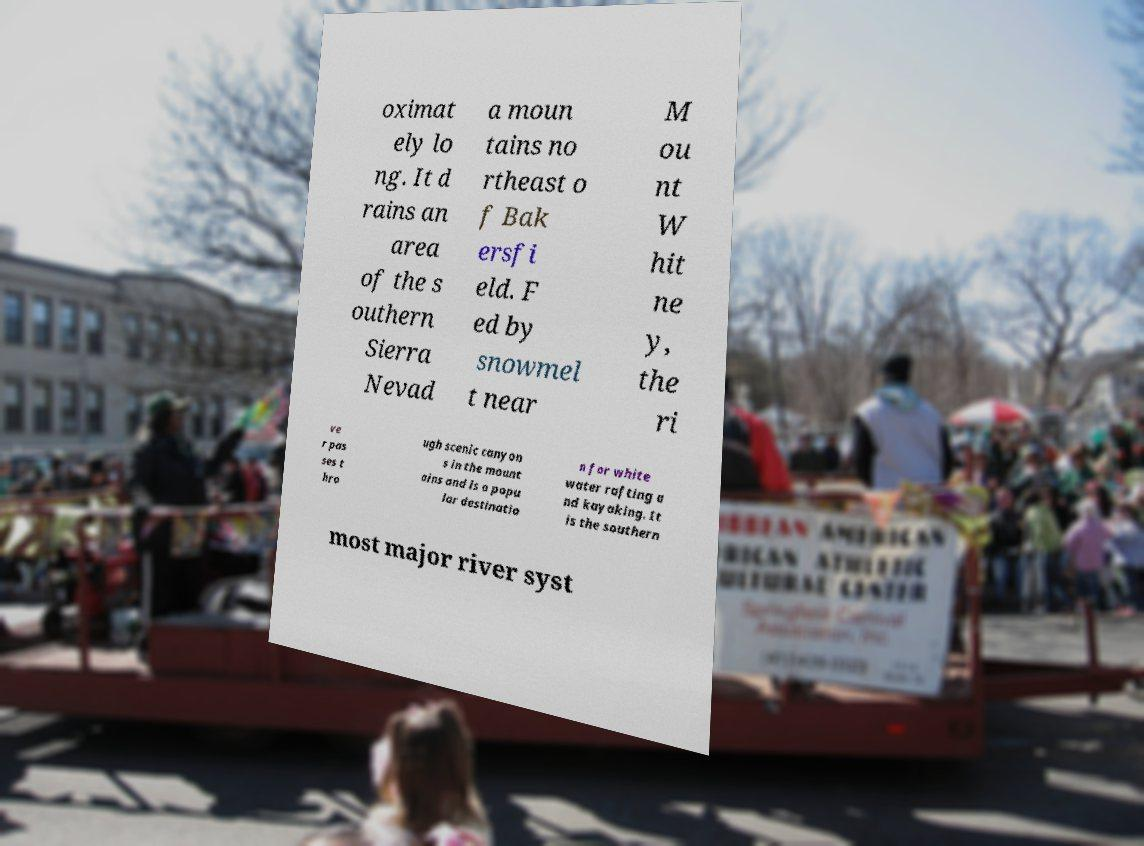Please identify and transcribe the text found in this image. oximat ely lo ng. It d rains an area of the s outhern Sierra Nevad a moun tains no rtheast o f Bak ersfi eld. F ed by snowmel t near M ou nt W hit ne y, the ri ve r pas ses t hro ugh scenic canyon s in the mount ains and is a popu lar destinatio n for white water rafting a nd kayaking. It is the southern most major river syst 